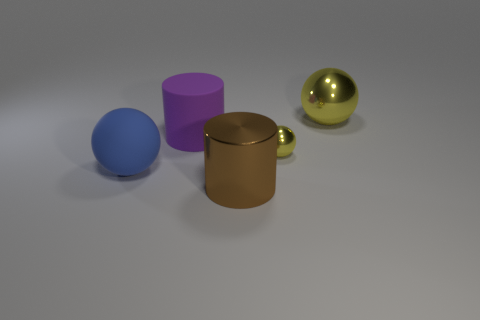How does the lighting in the image affect the appearance of the materials? The lighting in the image casts soft shadows and gives the objects a slightly muted look. The matte finish of the blue sphere diffuses light, while the glossy surface of the golden sphere and the rubber texture of the purple cylinder reflect light, enhancing their textures and highlighting their material differences. 